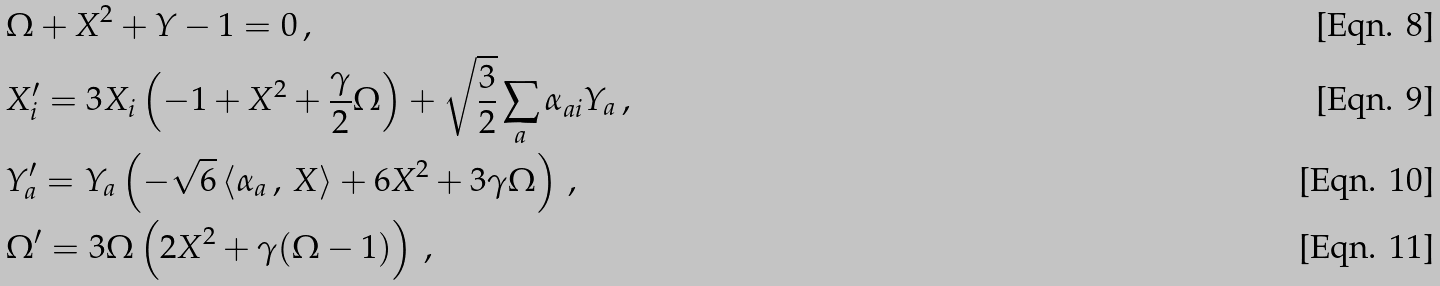Convert formula to latex. <formula><loc_0><loc_0><loc_500><loc_500>& \Omega + X ^ { 2 } + Y - 1 = 0 \, , \\ & X _ { i } ^ { \prime } = 3 X _ { i } \left ( - 1 + X ^ { 2 } + \frac { \gamma } { 2 } \Omega \right ) + \sqrt { \frac { 3 } { 2 } } \sum _ { a } \alpha _ { a i } Y _ { a } \, , \\ & Y ^ { \prime } _ { a } = Y _ { a } \left ( - \sqrt { 6 } \, \langle \alpha _ { a } \, , \, X \rangle + 6 X ^ { 2 } + 3 \gamma \Omega \right ) \, , \\ & \Omega ^ { \prime } = 3 \Omega \left ( 2 X ^ { 2 } + \gamma ( \Omega - 1 ) \right ) \, ,</formula> 